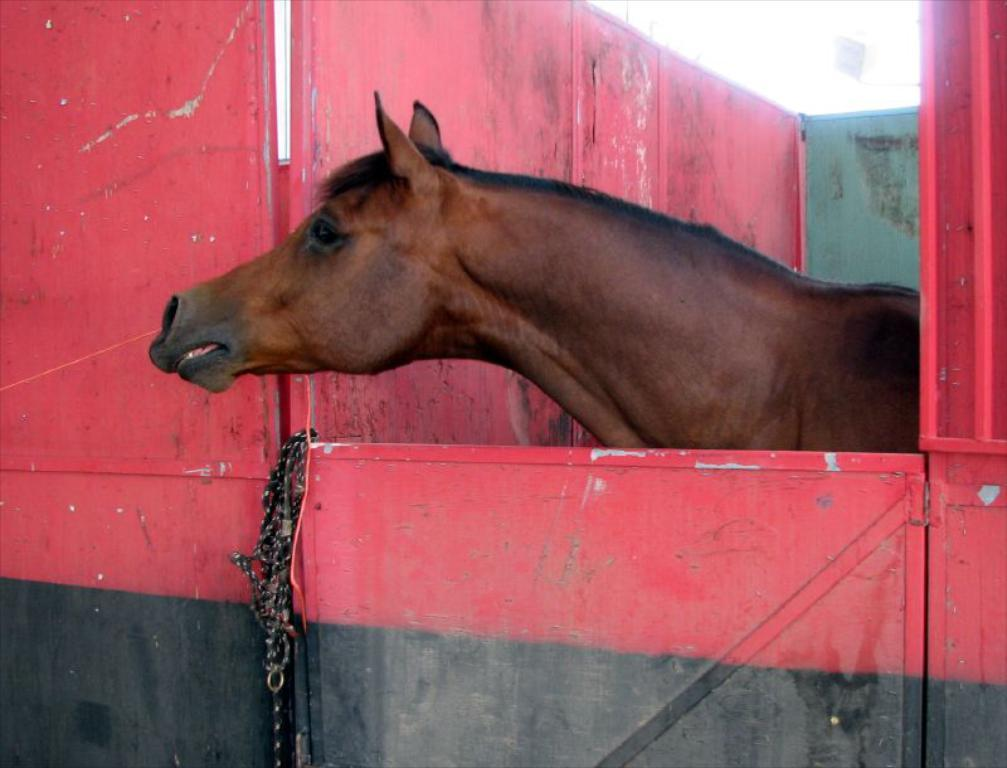What animal can be found in the stable in the image? There is a horse in the stable. What feature is present on the stable door? The door has a chain. What color are the horse and the stable? The horse and the stable are brown in color. How many volleyballs can be seen in the image? There are no volleyballs present in the image. What type of sponge is being used to clean the horse in the image? There is no sponge or cleaning activity depicted in the image. 